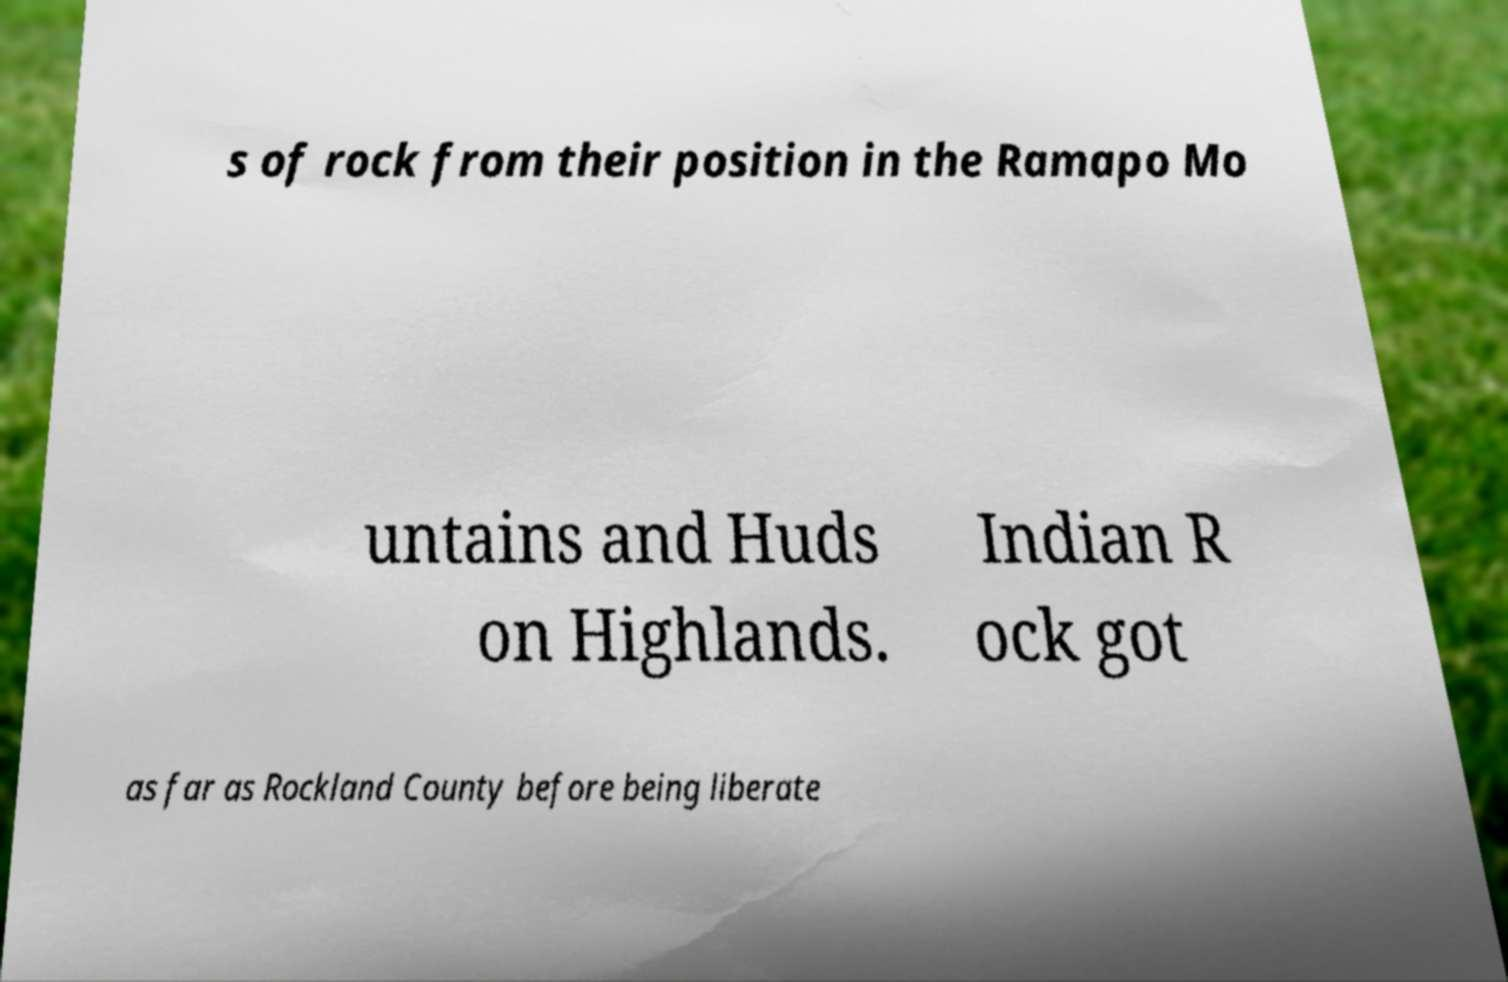Could you assist in decoding the text presented in this image and type it out clearly? s of rock from their position in the Ramapo Mo untains and Huds on Highlands. Indian R ock got as far as Rockland County before being liberate 